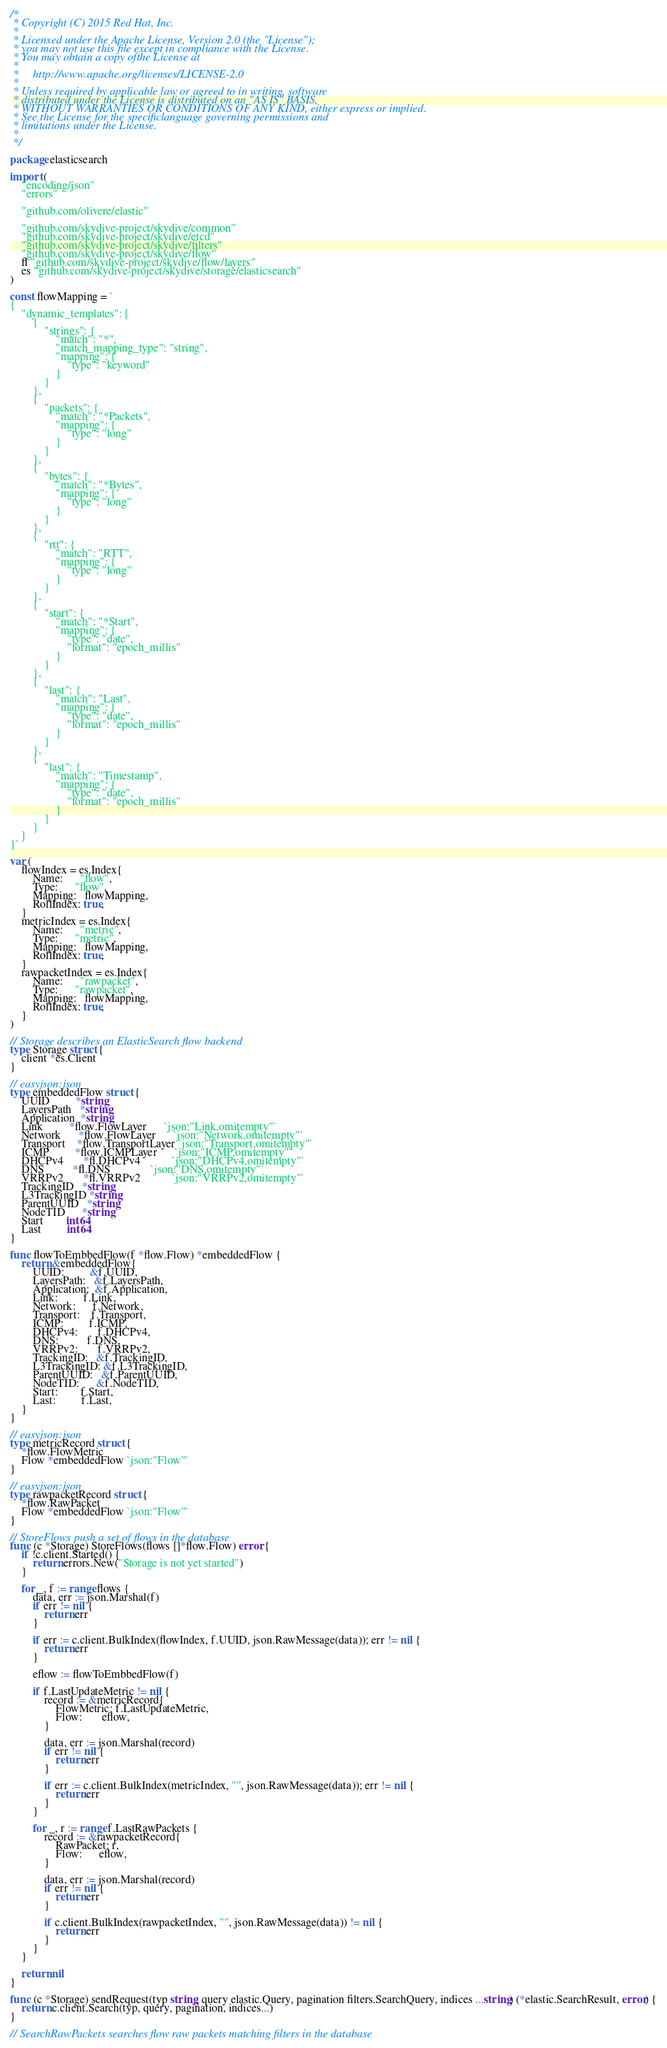Convert code to text. <code><loc_0><loc_0><loc_500><loc_500><_Go_>/*
 * Copyright (C) 2015 Red Hat, Inc.
 *
 * Licensed under the Apache License, Version 2.0 (the "License");
 * you may not use this file except in compliance with the License.
 * You may obtain a copy ofthe License at
 *
 *     http://www.apache.org/licenses/LICENSE-2.0
 *
 * Unless required by applicable law or agreed to in writing, software
 * distributed under the License is distributed on an "AS IS" BASIS,
 * WITHOUT WARRANTIES OR CONDITIONS OF ANY KIND, either express or implied.
 * See the License for the specificlanguage governing permissions and
 * limitations under the License.
 *
 */

package elasticsearch

import (
	"encoding/json"
	"errors"

	"github.com/olivere/elastic"

	"github.com/skydive-project/skydive/common"
	"github.com/skydive-project/skydive/etcd"
	"github.com/skydive-project/skydive/filters"
	"github.com/skydive-project/skydive/flow"
	fl "github.com/skydive-project/skydive/flow/layers"
	es "github.com/skydive-project/skydive/storage/elasticsearch"
)

const flowMapping = `
{
	"dynamic_templates": [
		{
			"strings": {
				"match": "*",
				"match_mapping_type": "string",
				"mapping": {
					"type": "keyword"
				}
			}
		},
		{
			"packets": {
				"match": "*Packets",
				"mapping": {
					"type": "long"
				}
			}
		},
		{
			"bytes": {
				"match": "*Bytes",
				"mapping": {
					"type": "long"
				}
			}
		},
		{
			"rtt": {
				"match": "RTT",
				"mapping": {
					"type": "long"
				}
			}
		},
		{
			"start": {
				"match": "*Start",
				"mapping": {
					"type": "date",
					"format": "epoch_millis"
				}
			}
		},
		{
			"last": {
				"match": "Last",
				"mapping": {
					"type": "date",
					"format": "epoch_millis"
				}
			}
		},
		{
			"last": {
				"match": "Timestamp",
				"mapping": {
					"type": "date",
					"format": "epoch_millis"
				}
			}
		}
	]
}`

var (
	flowIndex = es.Index{
		Name:      "flow",
		Type:      "flow",
		Mapping:   flowMapping,
		RollIndex: true,
	}
	metricIndex = es.Index{
		Name:      "metric",
		Type:      "metric",
		Mapping:   flowMapping,
		RollIndex: true,
	}
	rawpacketIndex = es.Index{
		Name:      "rawpacket",
		Type:      "rawpacket",
		Mapping:   flowMapping,
		RollIndex: true,
	}
)

// Storage describes an ElasticSearch flow backend
type Storage struct {
	client *es.Client
}

// easyjson:json
type embeddedFlow struct {
	UUID         *string
	LayersPath   *string
	Application  *string
	Link         *flow.FlowLayer      `json:"Link,omitempty"`
	Network      *flow.FlowLayer      `json:"Network,omitempty"`
	Transport    *flow.TransportLayer `json:"Transport,omitempty"`
	ICMP         *flow.ICMPLayer      `json:"ICMP,omitempty"`
	DHCPv4       *fl.DHCPv4           `json:"DHCPv4,omitempty"`
	DNS          *fl.DNS              `json:"DNS,omitempty"`
	VRRPv2       *fl.VRRPv2           `json:"VRRPv2,omitempty"`
	TrackingID   *string
	L3TrackingID *string
	ParentUUID   *string
	NodeTID      *string
	Start        int64
	Last         int64
}

func flowToEmbbedFlow(f *flow.Flow) *embeddedFlow {
	return &embeddedFlow{
		UUID:         &f.UUID,
		LayersPath:   &f.LayersPath,
		Application:  &f.Application,
		Link:         f.Link,
		Network:      f.Network,
		Transport:    f.Transport,
		ICMP:         f.ICMP,
		DHCPv4:       f.DHCPv4,
		DNS:          f.DNS,
		VRRPv2:       f.VRRPv2,
		TrackingID:   &f.TrackingID,
		L3TrackingID: &f.L3TrackingID,
		ParentUUID:   &f.ParentUUID,
		NodeTID:      &f.NodeTID,
		Start:        f.Start,
		Last:         f.Last,
	}
}

// easyjson:json
type metricRecord struct {
	*flow.FlowMetric
	Flow *embeddedFlow `json:"Flow"`
}

// easyjson:json
type rawpacketRecord struct {
	*flow.RawPacket
	Flow *embeddedFlow `json:"Flow"`
}

// StoreFlows push a set of flows in the database
func (c *Storage) StoreFlows(flows []*flow.Flow) error {
	if !c.client.Started() {
		return errors.New("Storage is not yet started")
	}

	for _, f := range flows {
		data, err := json.Marshal(f)
		if err != nil {
			return err
		}

		if err := c.client.BulkIndex(flowIndex, f.UUID, json.RawMessage(data)); err != nil {
			return err
		}

		eflow := flowToEmbbedFlow(f)

		if f.LastUpdateMetric != nil {
			record := &metricRecord{
				FlowMetric: f.LastUpdateMetric,
				Flow:       eflow,
			}

			data, err := json.Marshal(record)
			if err != nil {
				return err
			}

			if err := c.client.BulkIndex(metricIndex, "", json.RawMessage(data)); err != nil {
				return err
			}
		}

		for _, r := range f.LastRawPackets {
			record := &rawpacketRecord{
				RawPacket: r,
				Flow:      eflow,
			}

			data, err := json.Marshal(record)
			if err != nil {
				return err
			}

			if c.client.BulkIndex(rawpacketIndex, "", json.RawMessage(data)) != nil {
				return err
			}
		}
	}

	return nil
}

func (c *Storage) sendRequest(typ string, query elastic.Query, pagination filters.SearchQuery, indices ...string) (*elastic.SearchResult, error) {
	return c.client.Search(typ, query, pagination, indices...)
}

// SearchRawPackets searches flow raw packets matching filters in the database</code> 